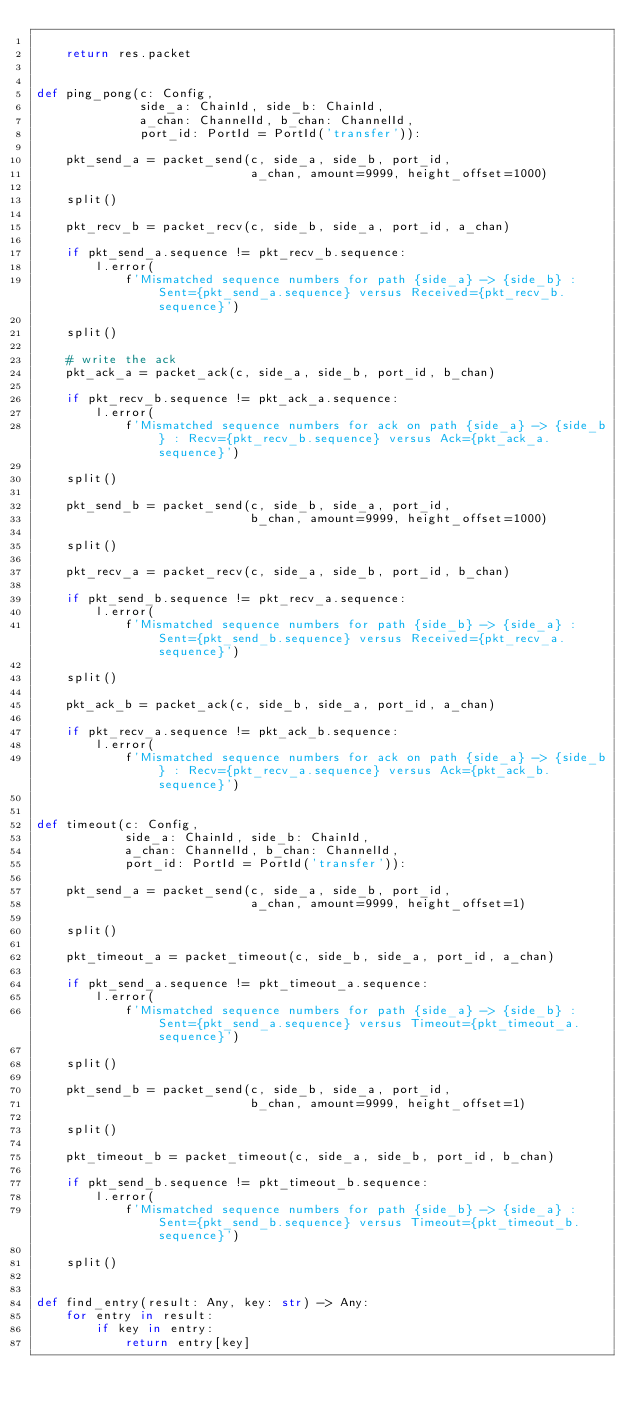Convert code to text. <code><loc_0><loc_0><loc_500><loc_500><_Python_>
    return res.packet


def ping_pong(c: Config,
              side_a: ChainId, side_b: ChainId,
              a_chan: ChannelId, b_chan: ChannelId,
              port_id: PortId = PortId('transfer')):

    pkt_send_a = packet_send(c, side_a, side_b, port_id,
                             a_chan, amount=9999, height_offset=1000)

    split()

    pkt_recv_b = packet_recv(c, side_b, side_a, port_id, a_chan)

    if pkt_send_a.sequence != pkt_recv_b.sequence:
        l.error(
            f'Mismatched sequence numbers for path {side_a} -> {side_b} : Sent={pkt_send_a.sequence} versus Received={pkt_recv_b.sequence}')

    split()

    # write the ack
    pkt_ack_a = packet_ack(c, side_a, side_b, port_id, b_chan)

    if pkt_recv_b.sequence != pkt_ack_a.sequence:
        l.error(
            f'Mismatched sequence numbers for ack on path {side_a} -> {side_b} : Recv={pkt_recv_b.sequence} versus Ack={pkt_ack_a.sequence}')

    split()

    pkt_send_b = packet_send(c, side_b, side_a, port_id,
                             b_chan, amount=9999, height_offset=1000)

    split()

    pkt_recv_a = packet_recv(c, side_a, side_b, port_id, b_chan)

    if pkt_send_b.sequence != pkt_recv_a.sequence:
        l.error(
            f'Mismatched sequence numbers for path {side_b} -> {side_a} : Sent={pkt_send_b.sequence} versus Received={pkt_recv_a.sequence}')

    split()

    pkt_ack_b = packet_ack(c, side_b, side_a, port_id, a_chan)

    if pkt_recv_a.sequence != pkt_ack_b.sequence:
        l.error(
            f'Mismatched sequence numbers for ack on path {side_a} -> {side_b} : Recv={pkt_recv_a.sequence} versus Ack={pkt_ack_b.sequence}')


def timeout(c: Config,
            side_a: ChainId, side_b: ChainId,
            a_chan: ChannelId, b_chan: ChannelId,
            port_id: PortId = PortId('transfer')):

    pkt_send_a = packet_send(c, side_a, side_b, port_id,
                             a_chan, amount=9999, height_offset=1)

    split()

    pkt_timeout_a = packet_timeout(c, side_b, side_a, port_id, a_chan)

    if pkt_send_a.sequence != pkt_timeout_a.sequence:
        l.error(
            f'Mismatched sequence numbers for path {side_a} -> {side_b} : Sent={pkt_send_a.sequence} versus Timeout={pkt_timeout_a.sequence}')

    split()

    pkt_send_b = packet_send(c, side_b, side_a, port_id,
                             b_chan, amount=9999, height_offset=1)

    split()

    pkt_timeout_b = packet_timeout(c, side_a, side_b, port_id, b_chan)

    if pkt_send_b.sequence != pkt_timeout_b.sequence:
        l.error(
            f'Mismatched sequence numbers for path {side_b} -> {side_a} : Sent={pkt_send_b.sequence} versus Timeout={pkt_timeout_b.sequence}')

    split()


def find_entry(result: Any, key: str) -> Any:
    for entry in result:
        if key in entry:
            return entry[key]
</code> 